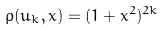<formula> <loc_0><loc_0><loc_500><loc_500>\rho ( u _ { k } , x ) = ( 1 + x ^ { 2 } ) ^ { 2 k }</formula> 